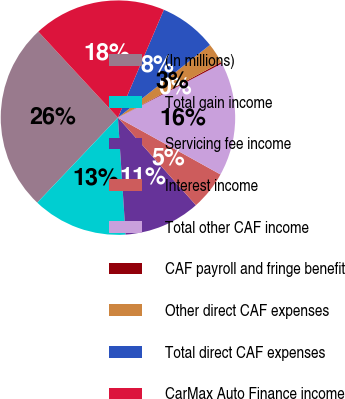Convert chart to OTSL. <chart><loc_0><loc_0><loc_500><loc_500><pie_chart><fcel>(In millions)<fcel>Total gain income<fcel>Servicing fee income<fcel>Interest income<fcel>Total other CAF income<fcel>CAF payroll and fringe benefit<fcel>Other direct CAF expenses<fcel>Total direct CAF expenses<fcel>CarMax Auto Finance income<nl><fcel>26.03%<fcel>13.12%<fcel>10.54%<fcel>5.37%<fcel>15.7%<fcel>0.21%<fcel>2.79%<fcel>7.95%<fcel>18.29%<nl></chart> 